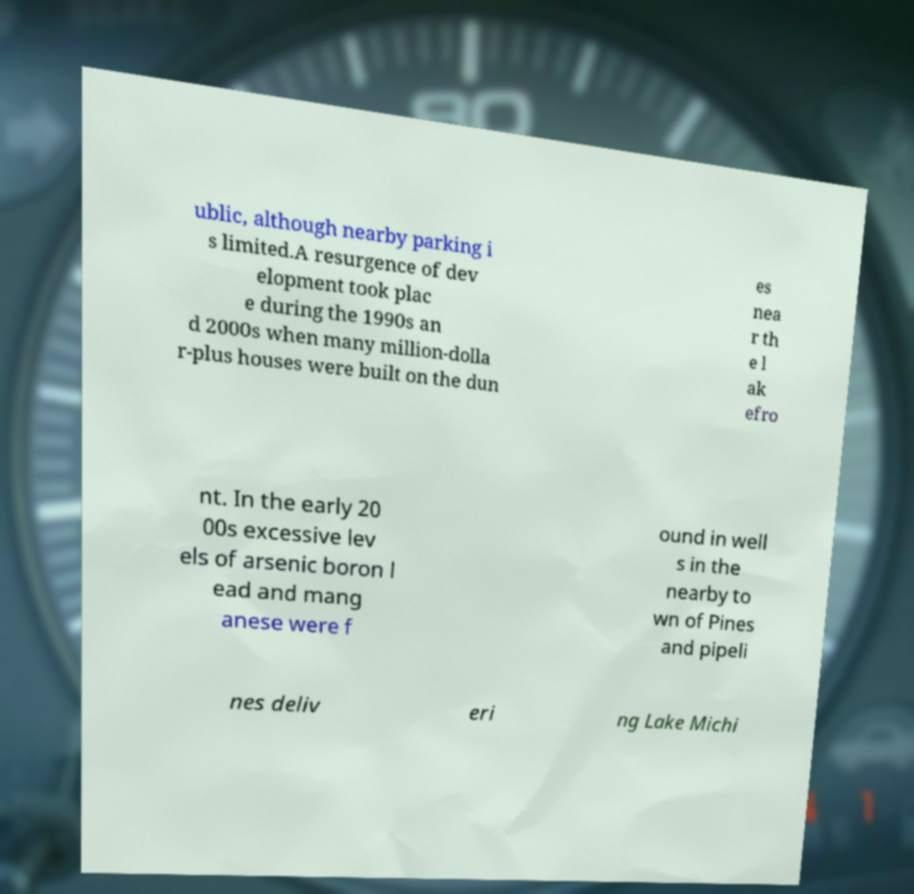What messages or text are displayed in this image? I need them in a readable, typed format. ublic, although nearby parking i s limited.A resurgence of dev elopment took plac e during the 1990s an d 2000s when many million-dolla r-plus houses were built on the dun es nea r th e l ak efro nt. In the early 20 00s excessive lev els of arsenic boron l ead and mang anese were f ound in well s in the nearby to wn of Pines and pipeli nes deliv eri ng Lake Michi 